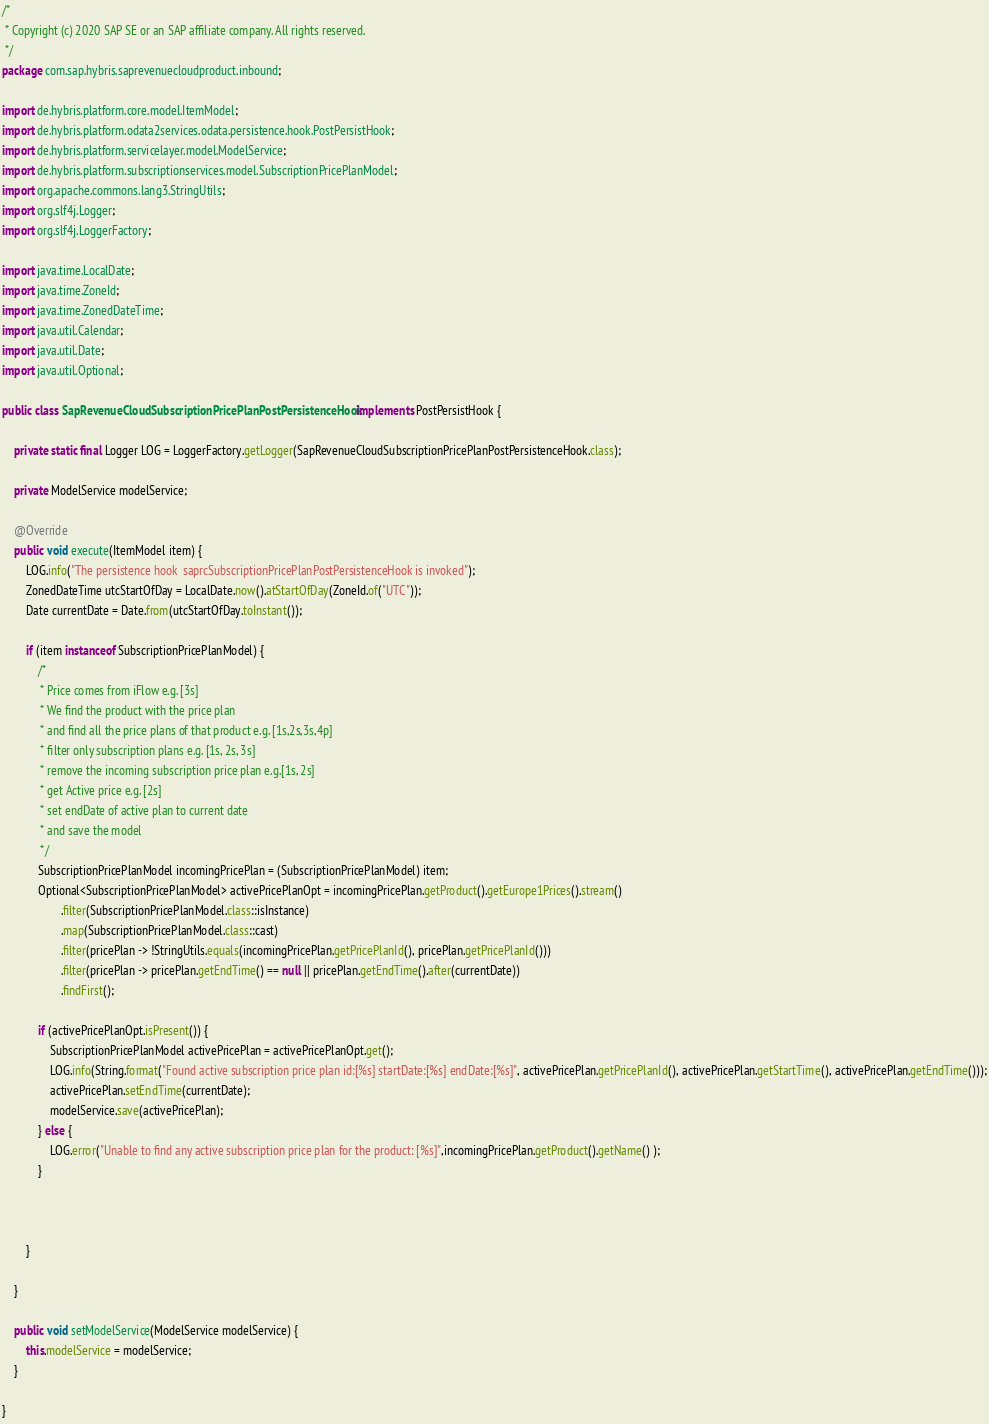Convert code to text. <code><loc_0><loc_0><loc_500><loc_500><_Java_>/*
 * Copyright (c) 2020 SAP SE or an SAP affiliate company. All rights reserved.
 */
package com.sap.hybris.saprevenuecloudproduct.inbound;

import de.hybris.platform.core.model.ItemModel;
import de.hybris.platform.odata2services.odata.persistence.hook.PostPersistHook;
import de.hybris.platform.servicelayer.model.ModelService;
import de.hybris.platform.subscriptionservices.model.SubscriptionPricePlanModel;
import org.apache.commons.lang3.StringUtils;
import org.slf4j.Logger;
import org.slf4j.LoggerFactory;

import java.time.LocalDate;
import java.time.ZoneId;
import java.time.ZonedDateTime;
import java.util.Calendar;
import java.util.Date;
import java.util.Optional;

public class SapRevenueCloudSubscriptionPricePlanPostPersistenceHook implements PostPersistHook {

    private static final Logger LOG = LoggerFactory.getLogger(SapRevenueCloudSubscriptionPricePlanPostPersistenceHook.class);

    private ModelService modelService;

    @Override
    public void execute(ItemModel item) {
        LOG.info("The persistence hook  saprcSubscriptionPricePlanPostPersistenceHook is invoked");
        ZonedDateTime utcStartOfDay = LocalDate.now().atStartOfDay(ZoneId.of("UTC"));
        Date currentDate = Date.from(utcStartOfDay.toInstant());

        if (item instanceof SubscriptionPricePlanModel) {
            /*
             * Price comes from iFlow e.g. [3s]
             * We find the product with the price plan
             * and find all the price plans of that product e.g. [1s,2s,3s,4p]
             * filter only subscription plans e.g. [1s, 2s, 3s]
             * remove the incoming subscription price plan e.g.[1s, 2s]
             * get Active price e.g. [2s]
             * set endDate of active plan to current date
             * and save the model
             */
            SubscriptionPricePlanModel incomingPricePlan = (SubscriptionPricePlanModel) item;
            Optional<SubscriptionPricePlanModel> activePricePlanOpt = incomingPricePlan.getProduct().getEurope1Prices().stream()
                    .filter(SubscriptionPricePlanModel.class::isInstance)
                    .map(SubscriptionPricePlanModel.class::cast)
                    .filter(pricePlan -> !StringUtils.equals(incomingPricePlan.getPricePlanId(), pricePlan.getPricePlanId()))
                    .filter(pricePlan -> pricePlan.getEndTime() == null || pricePlan.getEndTime().after(currentDate))
                    .findFirst();

            if (activePricePlanOpt.isPresent()) {
                SubscriptionPricePlanModel activePricePlan = activePricePlanOpt.get();
                LOG.info(String.format("Found active subscription price plan id:[%s] startDate:[%s] endDate:[%s]", activePricePlan.getPricePlanId(), activePricePlan.getStartTime(), activePricePlan.getEndTime()));
                activePricePlan.setEndTime(currentDate);
                modelService.save(activePricePlan);
            } else {
                LOG.error("Unable to find any active subscription price plan for the product: [%s]",incomingPricePlan.getProduct().getName() );
            }



        }

    }

    public void setModelService(ModelService modelService) {
        this.modelService = modelService;
    }

}</code> 